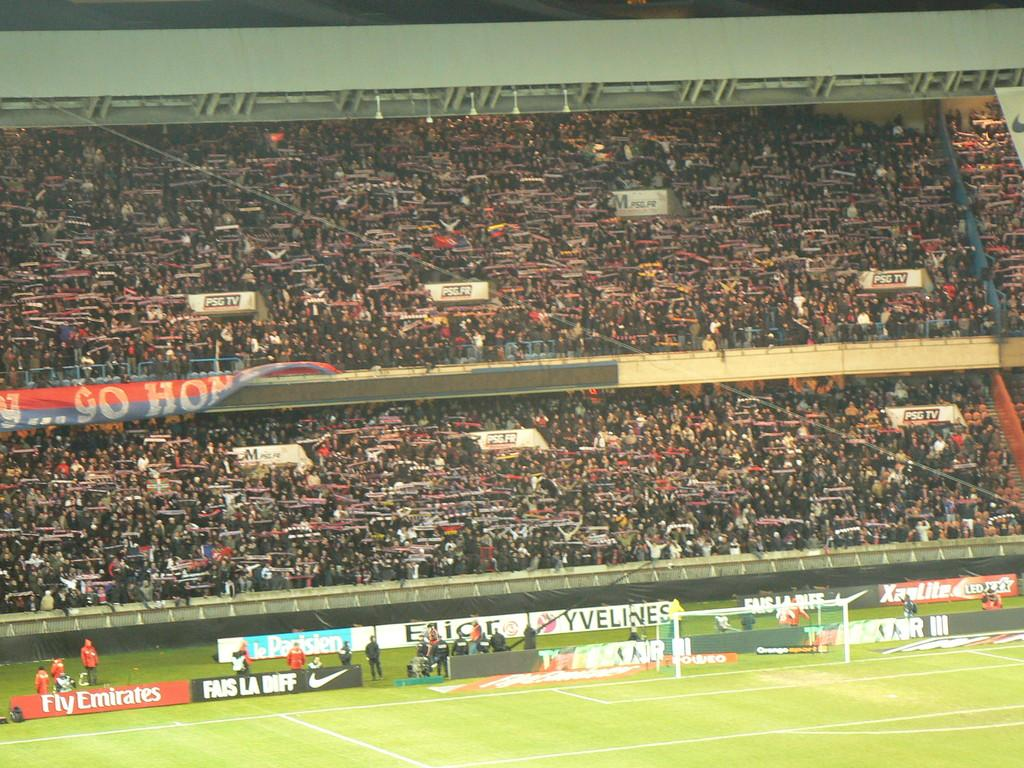What is visible on the ground in the image? The ground is visible in the image. What sports-related object can be seen in the image? There is a football net in the image. What type of decorations are present in the image? Posters are present in the image. What are the people in the foreground of the image doing? There are people standing on the grass in the image. What can be seen in the background of the image? In the background of the image, there is a group of people and a banner. Can you describe any other objects visible in the background of the image? There are other objects present in the background of the image. Can you see a man taking a bath in a tub in the image? There is no man taking a bath in a tub present in the image. Are there any mountains visible in the background of the image? There are no mountains visible in the image. 